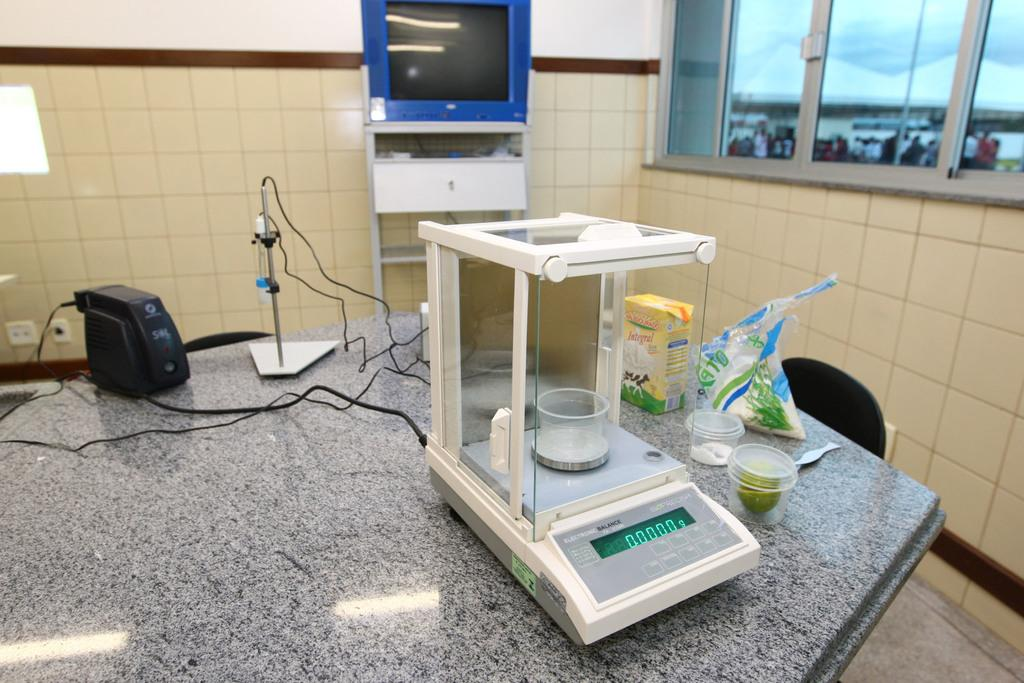<image>
Relay a brief, clear account of the picture shown. An electronic balance scale that is set at zero grams. 